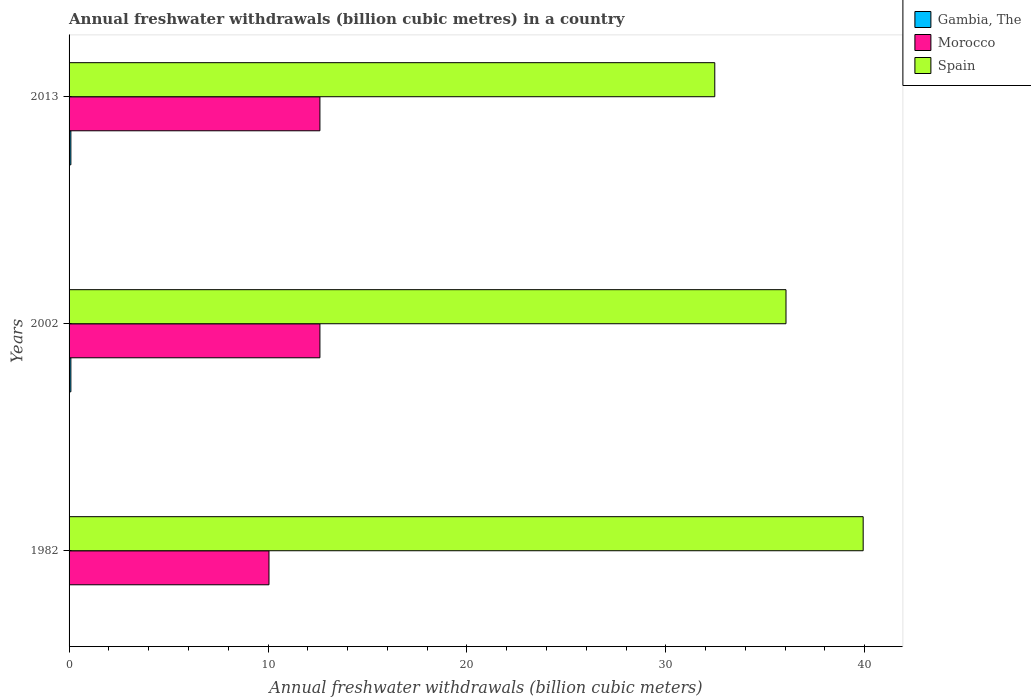How many different coloured bars are there?
Ensure brevity in your answer.  3. Are the number of bars per tick equal to the number of legend labels?
Your answer should be compact. Yes. How many bars are there on the 1st tick from the top?
Make the answer very short. 3. In how many cases, is the number of bars for a given year not equal to the number of legend labels?
Keep it short and to the point. 0. What is the annual freshwater withdrawals in Morocco in 1982?
Your answer should be compact. 10.05. Across all years, what is the maximum annual freshwater withdrawals in Spain?
Offer a terse response. 39.92. Across all years, what is the minimum annual freshwater withdrawals in Gambia, The?
Your answer should be very brief. 0.02. What is the total annual freshwater withdrawals in Spain in the graph?
Offer a very short reply. 108.42. What is the difference between the annual freshwater withdrawals in Gambia, The in 1982 and the annual freshwater withdrawals in Spain in 2002?
Your response must be concise. -36.02. What is the average annual freshwater withdrawals in Spain per year?
Offer a very short reply. 36.14. In the year 2013, what is the difference between the annual freshwater withdrawals in Spain and annual freshwater withdrawals in Gambia, The?
Your answer should be very brief. 32.37. What is the ratio of the annual freshwater withdrawals in Gambia, The in 1982 to that in 2002?
Provide a short and direct response. 0.22. Is the difference between the annual freshwater withdrawals in Spain in 2002 and 2013 greater than the difference between the annual freshwater withdrawals in Gambia, The in 2002 and 2013?
Provide a succinct answer. Yes. What is the difference between the highest and the second highest annual freshwater withdrawals in Gambia, The?
Give a very brief answer. 0. What is the difference between the highest and the lowest annual freshwater withdrawals in Gambia, The?
Keep it short and to the point. 0.07. Is the sum of the annual freshwater withdrawals in Gambia, The in 2002 and 2013 greater than the maximum annual freshwater withdrawals in Morocco across all years?
Provide a short and direct response. No. What does the 2nd bar from the top in 2002 represents?
Offer a terse response. Morocco. What does the 3rd bar from the bottom in 2002 represents?
Keep it short and to the point. Spain. How many bars are there?
Make the answer very short. 9. Are all the bars in the graph horizontal?
Your answer should be very brief. Yes. How many years are there in the graph?
Your answer should be compact. 3. Does the graph contain grids?
Give a very brief answer. No. Where does the legend appear in the graph?
Your answer should be compact. Top right. What is the title of the graph?
Offer a very short reply. Annual freshwater withdrawals (billion cubic metres) in a country. Does "Latin America(developing only)" appear as one of the legend labels in the graph?
Make the answer very short. No. What is the label or title of the X-axis?
Give a very brief answer. Annual freshwater withdrawals (billion cubic meters). What is the label or title of the Y-axis?
Your answer should be very brief. Years. What is the Annual freshwater withdrawals (billion cubic meters) of Gambia, The in 1982?
Offer a very short reply. 0.02. What is the Annual freshwater withdrawals (billion cubic meters) in Morocco in 1982?
Keep it short and to the point. 10.05. What is the Annual freshwater withdrawals (billion cubic meters) in Spain in 1982?
Give a very brief answer. 39.92. What is the Annual freshwater withdrawals (billion cubic meters) of Gambia, The in 2002?
Your answer should be compact. 0.09. What is the Annual freshwater withdrawals (billion cubic meters) of Morocco in 2002?
Your response must be concise. 12.61. What is the Annual freshwater withdrawals (billion cubic meters) in Spain in 2002?
Provide a succinct answer. 36.04. What is the Annual freshwater withdrawals (billion cubic meters) of Gambia, The in 2013?
Give a very brief answer. 0.09. What is the Annual freshwater withdrawals (billion cubic meters) of Morocco in 2013?
Offer a very short reply. 12.61. What is the Annual freshwater withdrawals (billion cubic meters) in Spain in 2013?
Keep it short and to the point. 32.46. Across all years, what is the maximum Annual freshwater withdrawals (billion cubic meters) of Gambia, The?
Your response must be concise. 0.09. Across all years, what is the maximum Annual freshwater withdrawals (billion cubic meters) of Morocco?
Ensure brevity in your answer.  12.61. Across all years, what is the maximum Annual freshwater withdrawals (billion cubic meters) of Spain?
Ensure brevity in your answer.  39.92. Across all years, what is the minimum Annual freshwater withdrawals (billion cubic meters) of Morocco?
Make the answer very short. 10.05. Across all years, what is the minimum Annual freshwater withdrawals (billion cubic meters) of Spain?
Your response must be concise. 32.46. What is the total Annual freshwater withdrawals (billion cubic meters) of Gambia, The in the graph?
Offer a terse response. 0.2. What is the total Annual freshwater withdrawals (billion cubic meters) in Morocco in the graph?
Offer a terse response. 35.27. What is the total Annual freshwater withdrawals (billion cubic meters) of Spain in the graph?
Your answer should be very brief. 108.42. What is the difference between the Annual freshwater withdrawals (billion cubic meters) in Gambia, The in 1982 and that in 2002?
Provide a succinct answer. -0.07. What is the difference between the Annual freshwater withdrawals (billion cubic meters) in Morocco in 1982 and that in 2002?
Offer a very short reply. -2.56. What is the difference between the Annual freshwater withdrawals (billion cubic meters) of Spain in 1982 and that in 2002?
Your answer should be compact. 3.88. What is the difference between the Annual freshwater withdrawals (billion cubic meters) in Gambia, The in 1982 and that in 2013?
Your response must be concise. -0.07. What is the difference between the Annual freshwater withdrawals (billion cubic meters) of Morocco in 1982 and that in 2013?
Offer a terse response. -2.56. What is the difference between the Annual freshwater withdrawals (billion cubic meters) of Spain in 1982 and that in 2013?
Ensure brevity in your answer.  7.46. What is the difference between the Annual freshwater withdrawals (billion cubic meters) in Morocco in 2002 and that in 2013?
Provide a short and direct response. 0. What is the difference between the Annual freshwater withdrawals (billion cubic meters) of Spain in 2002 and that in 2013?
Give a very brief answer. 3.58. What is the difference between the Annual freshwater withdrawals (billion cubic meters) of Gambia, The in 1982 and the Annual freshwater withdrawals (billion cubic meters) of Morocco in 2002?
Provide a short and direct response. -12.59. What is the difference between the Annual freshwater withdrawals (billion cubic meters) in Gambia, The in 1982 and the Annual freshwater withdrawals (billion cubic meters) in Spain in 2002?
Offer a terse response. -36.02. What is the difference between the Annual freshwater withdrawals (billion cubic meters) of Morocco in 1982 and the Annual freshwater withdrawals (billion cubic meters) of Spain in 2002?
Provide a succinct answer. -25.99. What is the difference between the Annual freshwater withdrawals (billion cubic meters) of Gambia, The in 1982 and the Annual freshwater withdrawals (billion cubic meters) of Morocco in 2013?
Give a very brief answer. -12.59. What is the difference between the Annual freshwater withdrawals (billion cubic meters) in Gambia, The in 1982 and the Annual freshwater withdrawals (billion cubic meters) in Spain in 2013?
Your answer should be compact. -32.44. What is the difference between the Annual freshwater withdrawals (billion cubic meters) of Morocco in 1982 and the Annual freshwater withdrawals (billion cubic meters) of Spain in 2013?
Offer a very short reply. -22.41. What is the difference between the Annual freshwater withdrawals (billion cubic meters) of Gambia, The in 2002 and the Annual freshwater withdrawals (billion cubic meters) of Morocco in 2013?
Your answer should be compact. -12.52. What is the difference between the Annual freshwater withdrawals (billion cubic meters) of Gambia, The in 2002 and the Annual freshwater withdrawals (billion cubic meters) of Spain in 2013?
Make the answer very short. -32.37. What is the difference between the Annual freshwater withdrawals (billion cubic meters) of Morocco in 2002 and the Annual freshwater withdrawals (billion cubic meters) of Spain in 2013?
Keep it short and to the point. -19.85. What is the average Annual freshwater withdrawals (billion cubic meters) of Gambia, The per year?
Your response must be concise. 0.07. What is the average Annual freshwater withdrawals (billion cubic meters) in Morocco per year?
Provide a succinct answer. 11.76. What is the average Annual freshwater withdrawals (billion cubic meters) in Spain per year?
Offer a terse response. 36.14. In the year 1982, what is the difference between the Annual freshwater withdrawals (billion cubic meters) in Gambia, The and Annual freshwater withdrawals (billion cubic meters) in Morocco?
Provide a succinct answer. -10.03. In the year 1982, what is the difference between the Annual freshwater withdrawals (billion cubic meters) of Gambia, The and Annual freshwater withdrawals (billion cubic meters) of Spain?
Make the answer very short. -39.9. In the year 1982, what is the difference between the Annual freshwater withdrawals (billion cubic meters) in Morocco and Annual freshwater withdrawals (billion cubic meters) in Spain?
Ensure brevity in your answer.  -29.87. In the year 2002, what is the difference between the Annual freshwater withdrawals (billion cubic meters) in Gambia, The and Annual freshwater withdrawals (billion cubic meters) in Morocco?
Your answer should be compact. -12.52. In the year 2002, what is the difference between the Annual freshwater withdrawals (billion cubic meters) in Gambia, The and Annual freshwater withdrawals (billion cubic meters) in Spain?
Your answer should be compact. -35.95. In the year 2002, what is the difference between the Annual freshwater withdrawals (billion cubic meters) in Morocco and Annual freshwater withdrawals (billion cubic meters) in Spain?
Make the answer very short. -23.43. In the year 2013, what is the difference between the Annual freshwater withdrawals (billion cubic meters) in Gambia, The and Annual freshwater withdrawals (billion cubic meters) in Morocco?
Provide a short and direct response. -12.52. In the year 2013, what is the difference between the Annual freshwater withdrawals (billion cubic meters) in Gambia, The and Annual freshwater withdrawals (billion cubic meters) in Spain?
Your answer should be very brief. -32.37. In the year 2013, what is the difference between the Annual freshwater withdrawals (billion cubic meters) in Morocco and Annual freshwater withdrawals (billion cubic meters) in Spain?
Provide a succinct answer. -19.85. What is the ratio of the Annual freshwater withdrawals (billion cubic meters) of Gambia, The in 1982 to that in 2002?
Ensure brevity in your answer.  0.22. What is the ratio of the Annual freshwater withdrawals (billion cubic meters) in Morocco in 1982 to that in 2002?
Ensure brevity in your answer.  0.8. What is the ratio of the Annual freshwater withdrawals (billion cubic meters) of Spain in 1982 to that in 2002?
Your answer should be very brief. 1.11. What is the ratio of the Annual freshwater withdrawals (billion cubic meters) of Gambia, The in 1982 to that in 2013?
Provide a succinct answer. 0.22. What is the ratio of the Annual freshwater withdrawals (billion cubic meters) of Morocco in 1982 to that in 2013?
Provide a succinct answer. 0.8. What is the ratio of the Annual freshwater withdrawals (billion cubic meters) of Spain in 1982 to that in 2013?
Your answer should be compact. 1.23. What is the ratio of the Annual freshwater withdrawals (billion cubic meters) of Gambia, The in 2002 to that in 2013?
Offer a terse response. 1. What is the ratio of the Annual freshwater withdrawals (billion cubic meters) in Morocco in 2002 to that in 2013?
Your answer should be very brief. 1. What is the ratio of the Annual freshwater withdrawals (billion cubic meters) in Spain in 2002 to that in 2013?
Keep it short and to the point. 1.11. What is the difference between the highest and the second highest Annual freshwater withdrawals (billion cubic meters) in Gambia, The?
Provide a short and direct response. 0. What is the difference between the highest and the second highest Annual freshwater withdrawals (billion cubic meters) of Spain?
Make the answer very short. 3.88. What is the difference between the highest and the lowest Annual freshwater withdrawals (billion cubic meters) of Gambia, The?
Offer a terse response. 0.07. What is the difference between the highest and the lowest Annual freshwater withdrawals (billion cubic meters) in Morocco?
Keep it short and to the point. 2.56. What is the difference between the highest and the lowest Annual freshwater withdrawals (billion cubic meters) in Spain?
Your response must be concise. 7.46. 